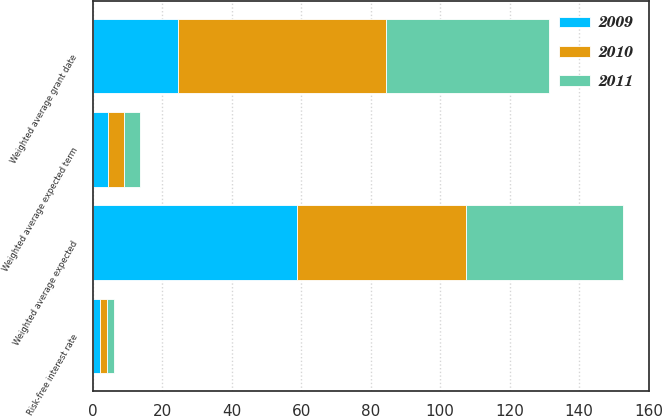<chart> <loc_0><loc_0><loc_500><loc_500><stacked_bar_chart><ecel><fcel>Weighted average expected term<fcel>Weighted average expected<fcel>Risk-free interest rate<fcel>Weighted average grant date<nl><fcel>2010<fcel>4.6<fcel>48.7<fcel>2<fcel>59.69<nl><fcel>2011<fcel>4.5<fcel>45.1<fcel>2.23<fcel>46.96<nl><fcel>2009<fcel>4.5<fcel>58.8<fcel>2<fcel>24.61<nl></chart> 